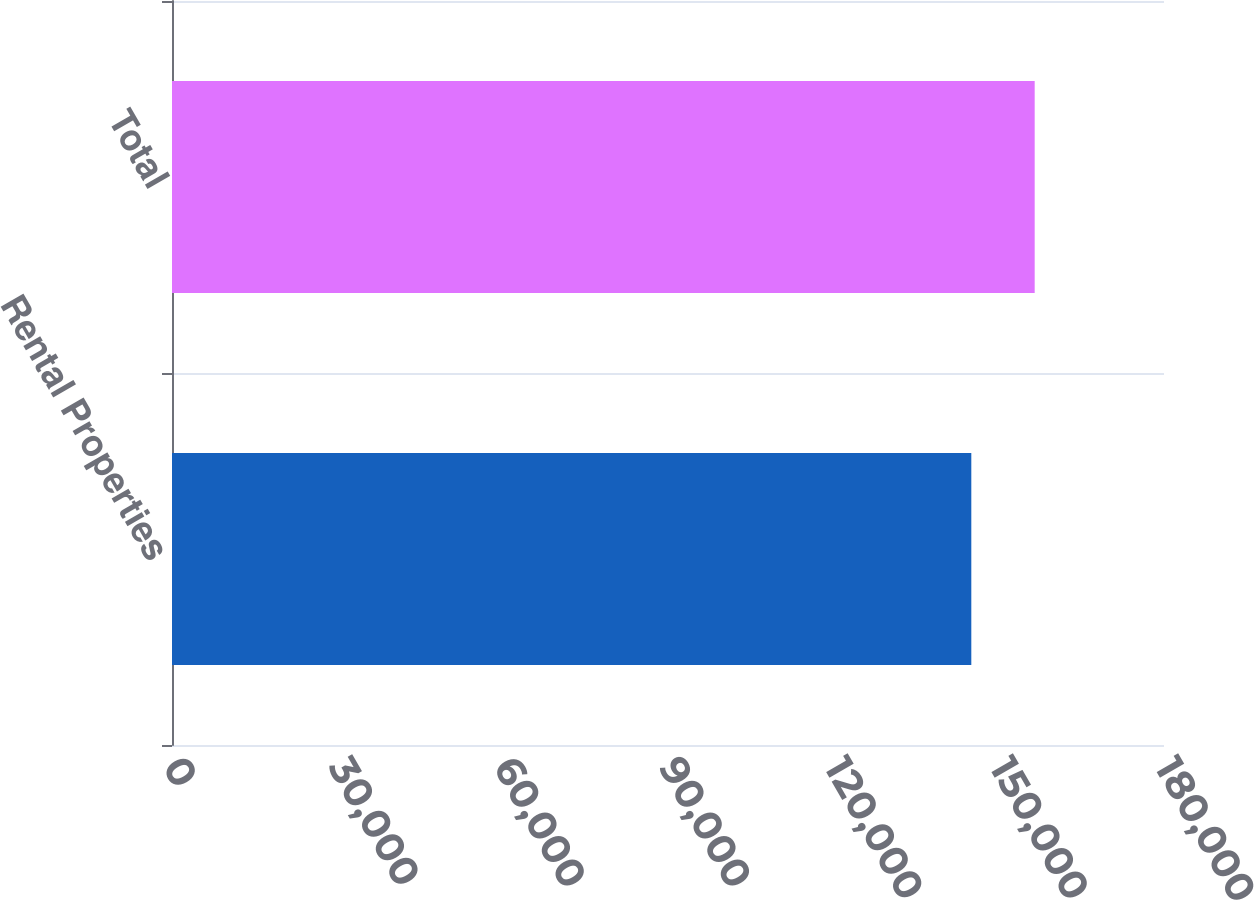Convert chart to OTSL. <chart><loc_0><loc_0><loc_500><loc_500><bar_chart><fcel>Rental Properties<fcel>Total<nl><fcel>145036<fcel>156536<nl></chart> 